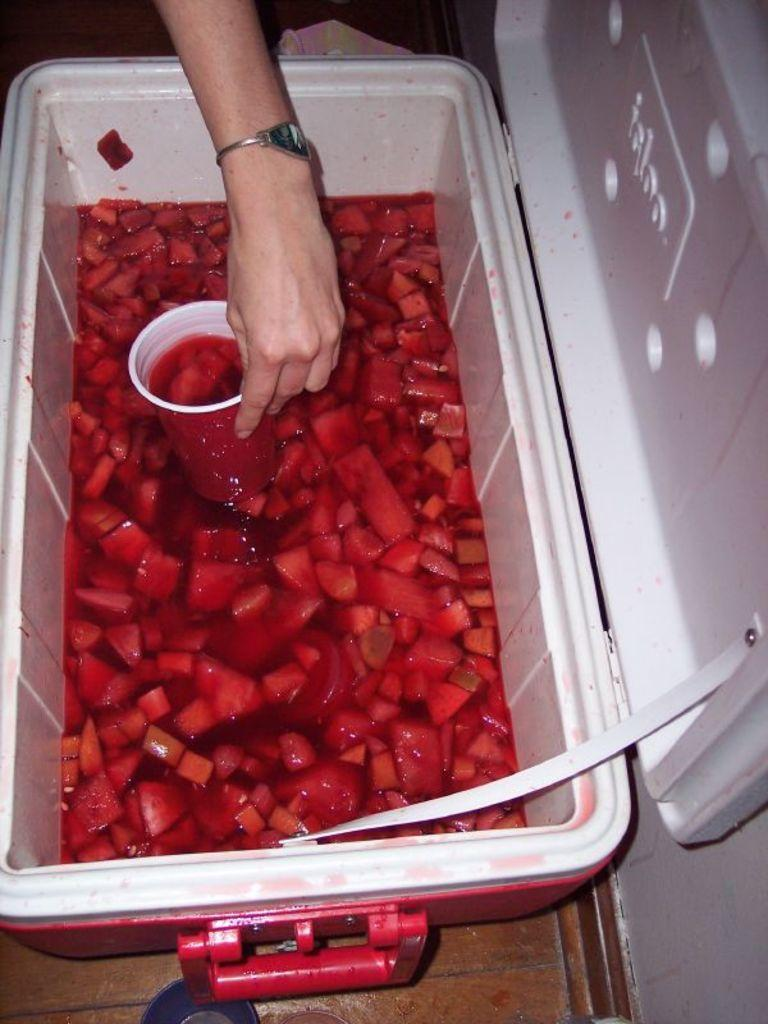What is inside the container in the image? The container has pieces of fruits mixed in water. What else can be seen in the image besides the container? There is a glass in the image. Whose hand is visible in the image? A human hand is visible in the image. What accessory is worn by the person in the image? A wrist watch is present in the image. What surface is the container and glass placed on? There is a floor in the image. Is the person in the image in trouble with the law, as indicated by the presence of a jail? There is no indication of a jail or any legal trouble in the image; it only shows a container with mixed fruits, a glass, a human hand, a wrist watch, and a floor. 